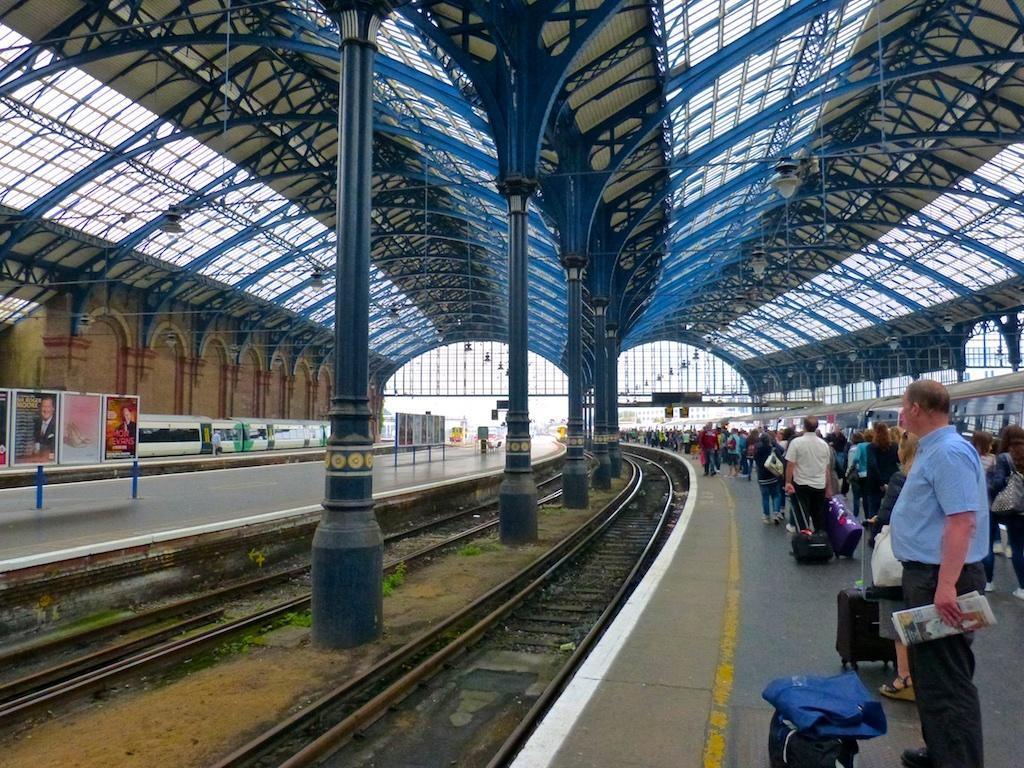In one or two sentences, can you explain what this image depicts? There are people carrying their luggage on the right side of the image on the platform, there is a train on the right side. There are poles and tracks in the center and posters, another train and platform on the left side, there is roof at the top side. 